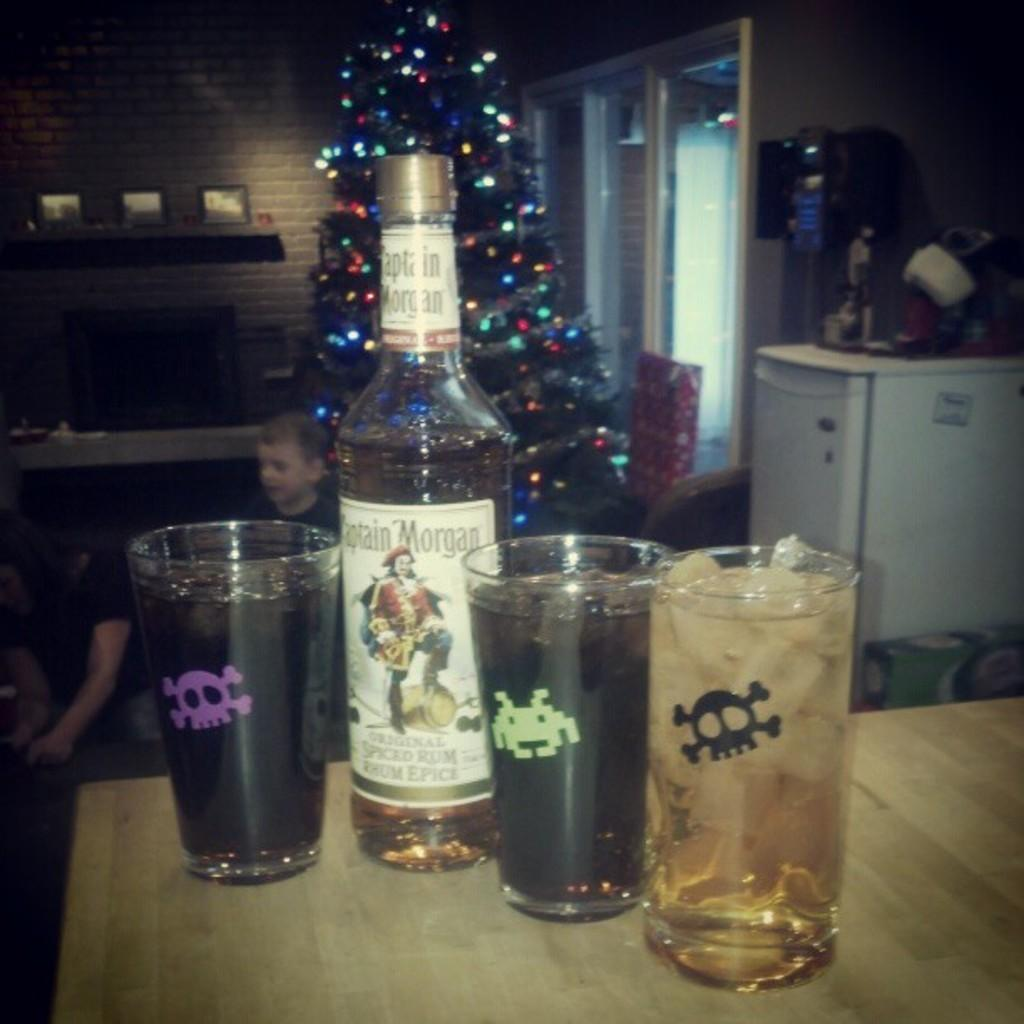<image>
Render a clear and concise summary of the photo. A bottle of Captain Morgan next to three drinks. 